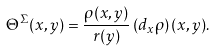<formula> <loc_0><loc_0><loc_500><loc_500>\Theta ^ { \Sigma } ( x , y ) = \frac { \rho ( x , y ) } { r ( y ) } \left ( d _ { x } \rho \right ) ( x , y ) .</formula> 